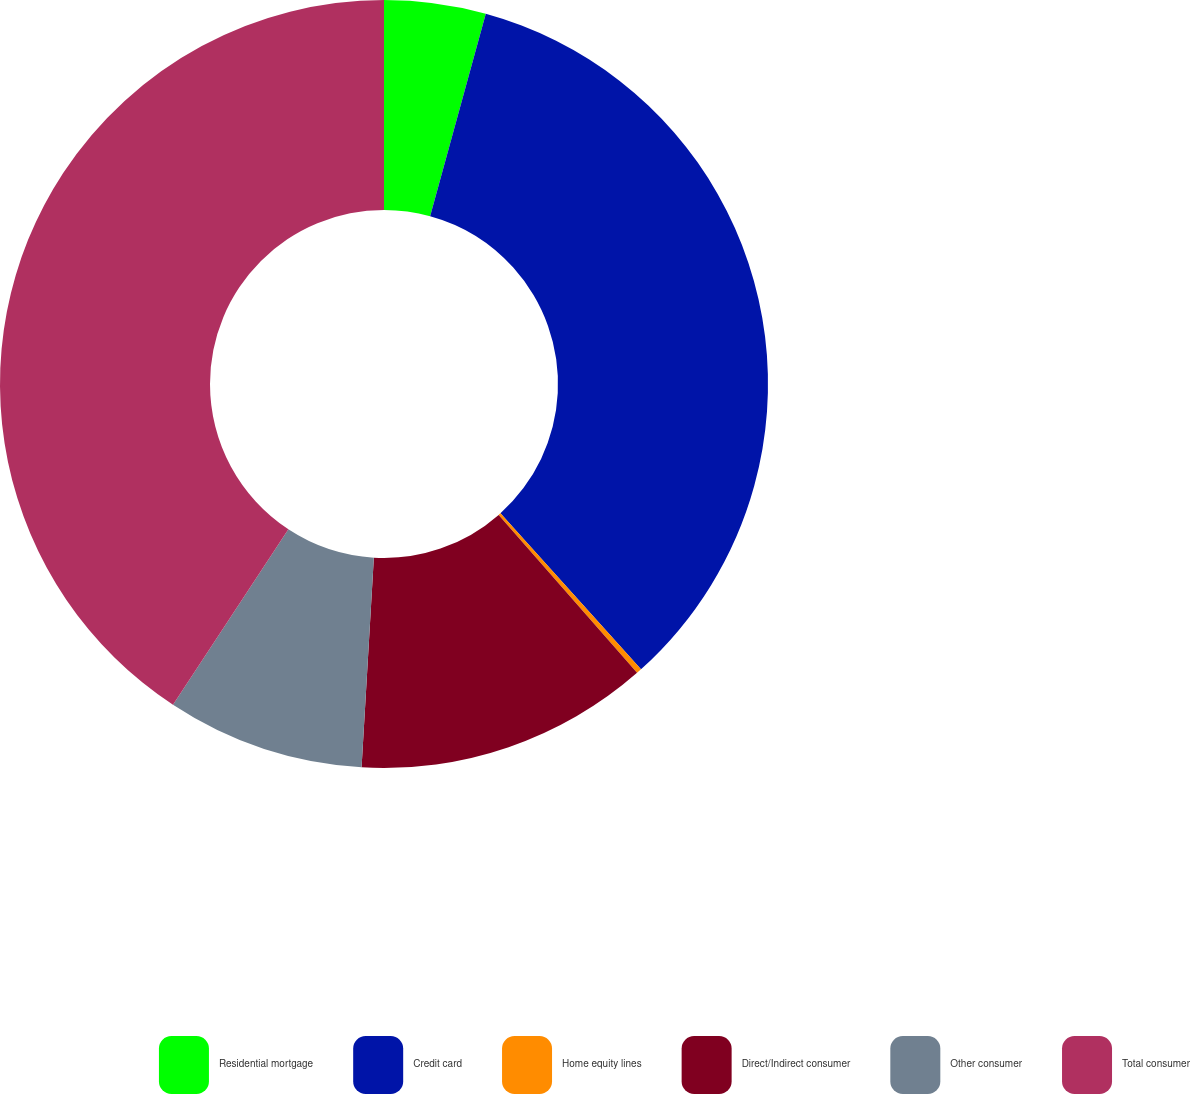<chart> <loc_0><loc_0><loc_500><loc_500><pie_chart><fcel>Residential mortgage<fcel>Credit card<fcel>Home equity lines<fcel>Direct/Indirect consumer<fcel>Other consumer<fcel>Total consumer<nl><fcel>4.27%<fcel>34.06%<fcel>0.22%<fcel>12.38%<fcel>8.33%<fcel>40.74%<nl></chart> 